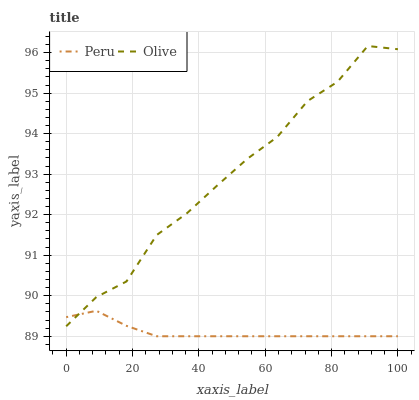Does Peru have the minimum area under the curve?
Answer yes or no. Yes. Does Olive have the maximum area under the curve?
Answer yes or no. Yes. Does Peru have the maximum area under the curve?
Answer yes or no. No. Is Peru the smoothest?
Answer yes or no. Yes. Is Olive the roughest?
Answer yes or no. Yes. Is Peru the roughest?
Answer yes or no. No. Does Olive have the highest value?
Answer yes or no. Yes. Does Peru have the highest value?
Answer yes or no. No. Does Olive intersect Peru?
Answer yes or no. Yes. Is Olive less than Peru?
Answer yes or no. No. Is Olive greater than Peru?
Answer yes or no. No. 